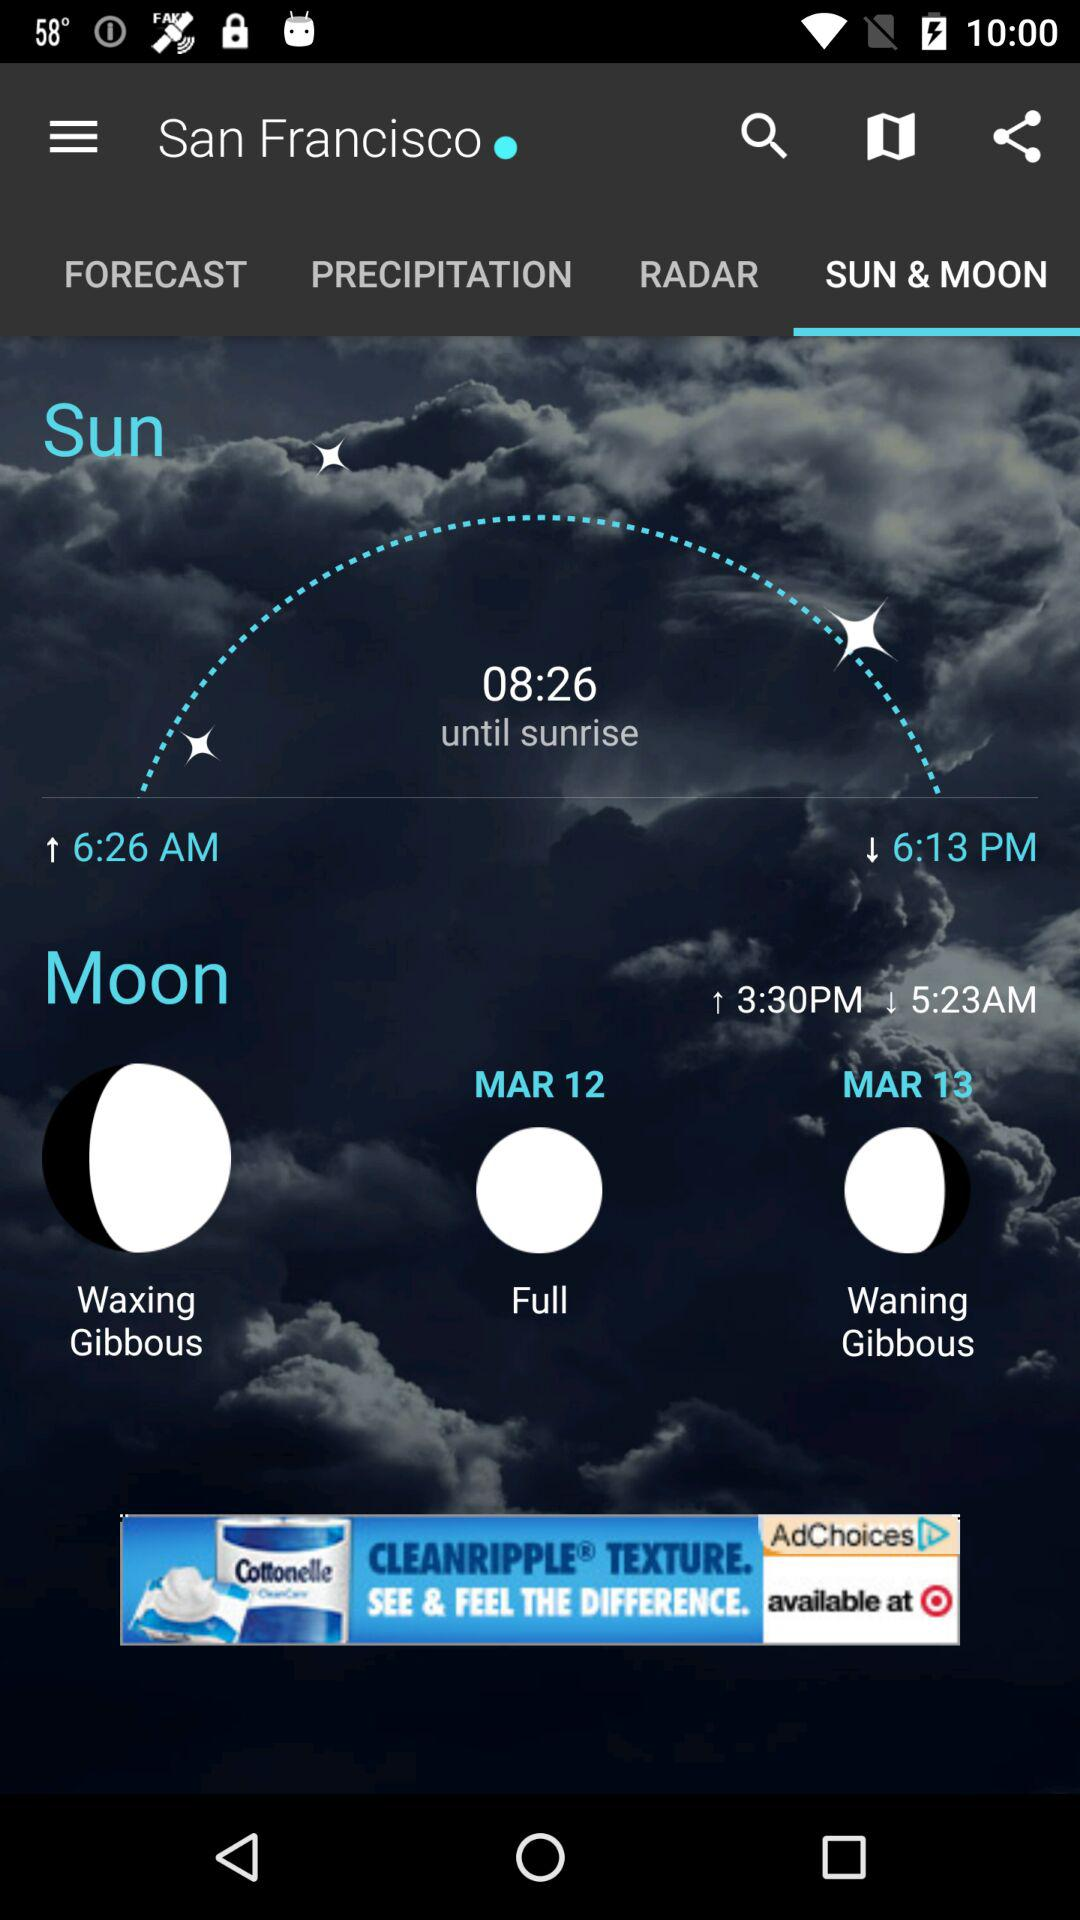Which tab am I on? You are on the "SUN & MOON" tab. 